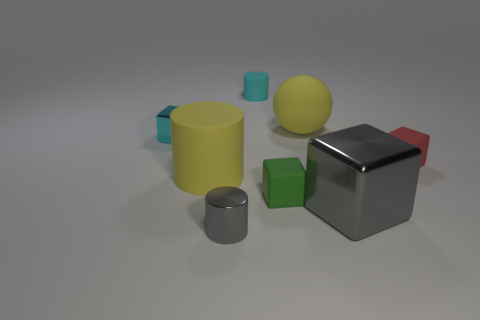Can you describe the lighting and shadows in the image? The lighting in the image seems to come from above, casting soft shadows beneath each object. The shadows are subtle and suggest a diffused light source, creating a calm and balanced atmosphere within the scene.  If this were a real physical setup, what materials could the objects be made of? If this setup were physical, the objects could be made from various materials. The shiny grey cube might be metallic, the yellow and red objects could be made of matte plastic, and the green cubes may be of a similar plastic with a slightly different finish, whilst the cyan cylinders appear to be a translucent plastic. 